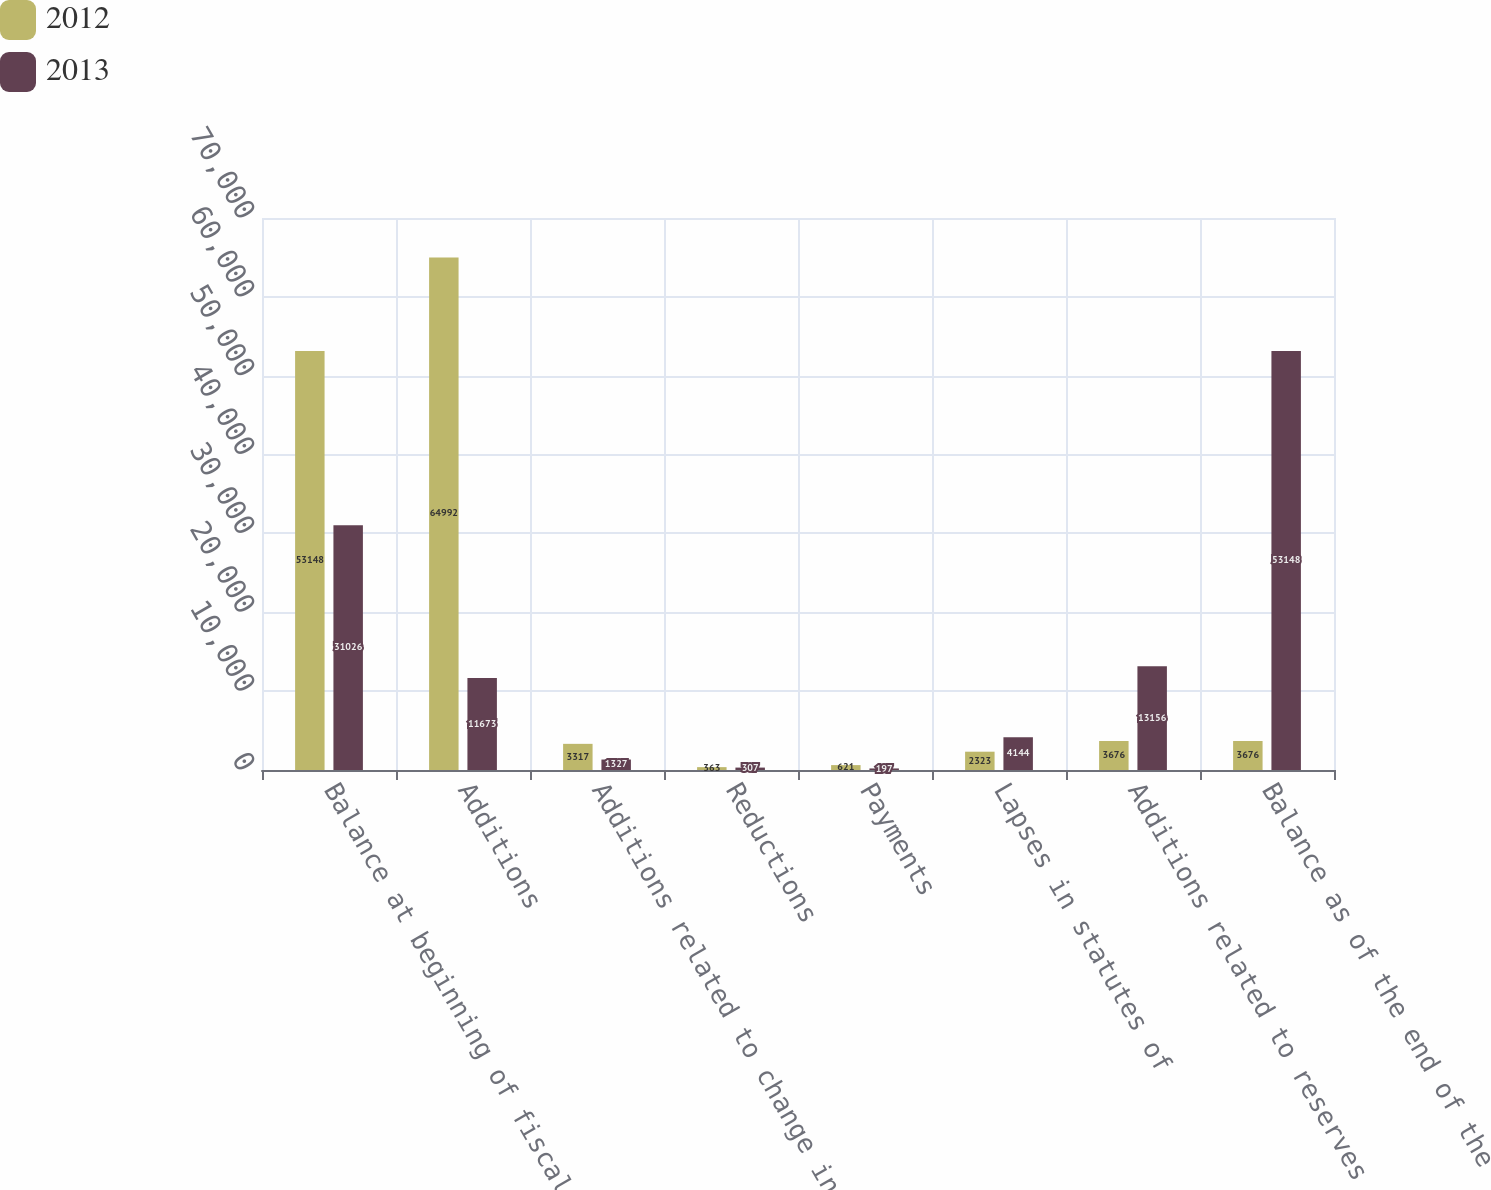Convert chart to OTSL. <chart><loc_0><loc_0><loc_500><loc_500><stacked_bar_chart><ecel><fcel>Balance at beginning of fiscal<fcel>Additions<fcel>Additions related to change in<fcel>Reductions<fcel>Payments<fcel>Lapses in statutes of<fcel>Additions related to reserves<fcel>Balance as of the end of the<nl><fcel>2012<fcel>53148<fcel>64992<fcel>3317<fcel>363<fcel>621<fcel>2323<fcel>3676<fcel>3676<nl><fcel>2013<fcel>31026<fcel>11673<fcel>1327<fcel>307<fcel>197<fcel>4144<fcel>13156<fcel>53148<nl></chart> 